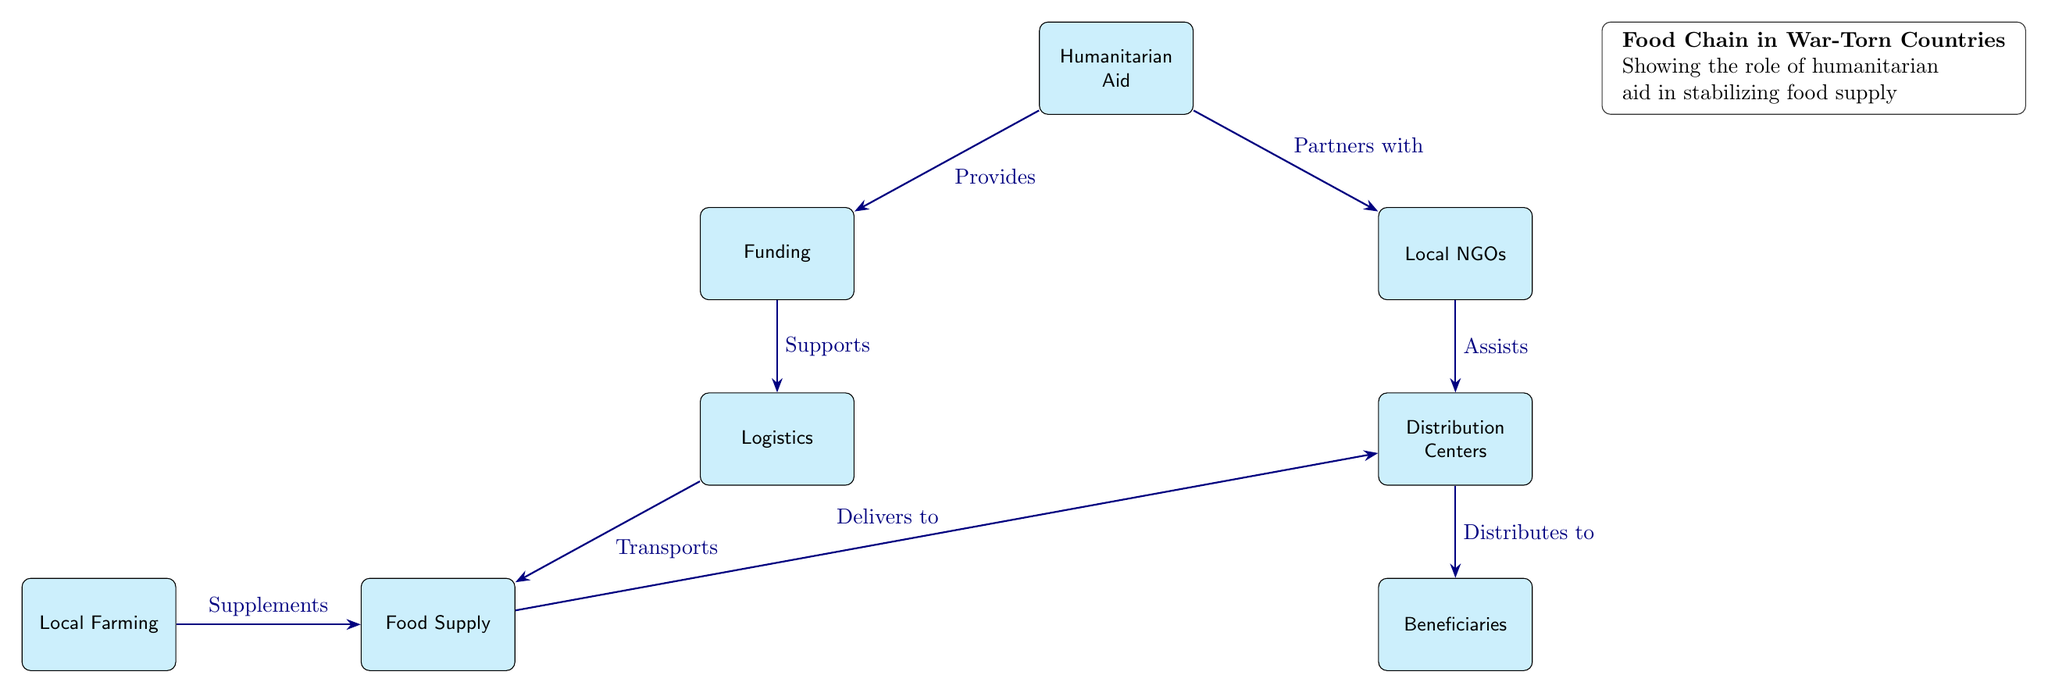What does humanitarian aid provide? The diagram shows that humanitarian aid provides funding, as indicated by the directed arrow from the "Humanitarian Aid" node to the "Funding" node labeled "Provides."
Answer: Funding Who partners with local NGOs? According to the diagram, humanitarian aid partners with local NGOs, which is illustrated by the directed arrow from the "Humanitarian Aid" node to the "Local NGOs" node labeled "Partners with."
Answer: Humanitarian Aid What supports logistics? The "Funding" node supports logistics, as shown by the arrow from "Funding" to "Logistics" labeled "Supports."
Answer: Funding How is food delivered to distribution centers? Food is delivered to distribution centers through a transport process, as depicted by the arrow from the "Food Supply" node to the "Distribution Centers" labeled "Delivers to."
Answer: Transports What supplements the food supply? The diagram specifies that local farming supplements the food supply, indicated by the arrow from the "Local Farming" node to the "Food Supply" node labeled "Supplements."
Answer: Local Farming What is the final recipient of food in this chain? The final recipient of food in this chain is the beneficiaries, as indicated by the arrow leading from "Distribution Centers" to "Beneficiaries" labeled "Distributes to."
Answer: Beneficiaries How many nodes are in the diagram? To find the number of nodes, we can count each unique box present in the diagram, which totals eight.
Answer: Eight Which node is connected to both funding and local NGOs? The node connected to both funding and local NGOs is the humanitarian aid node, as it has arrows pointing towards both "Funding" and "Local NGOs."
Answer: Humanitarian Aid What is the role of logistics in this food chain? The role of logistics in this food chain is to transport food supply, as indicated by the arrow from "Logistics" to "Food Supply" labeled "Transports."
Answer: Transports 